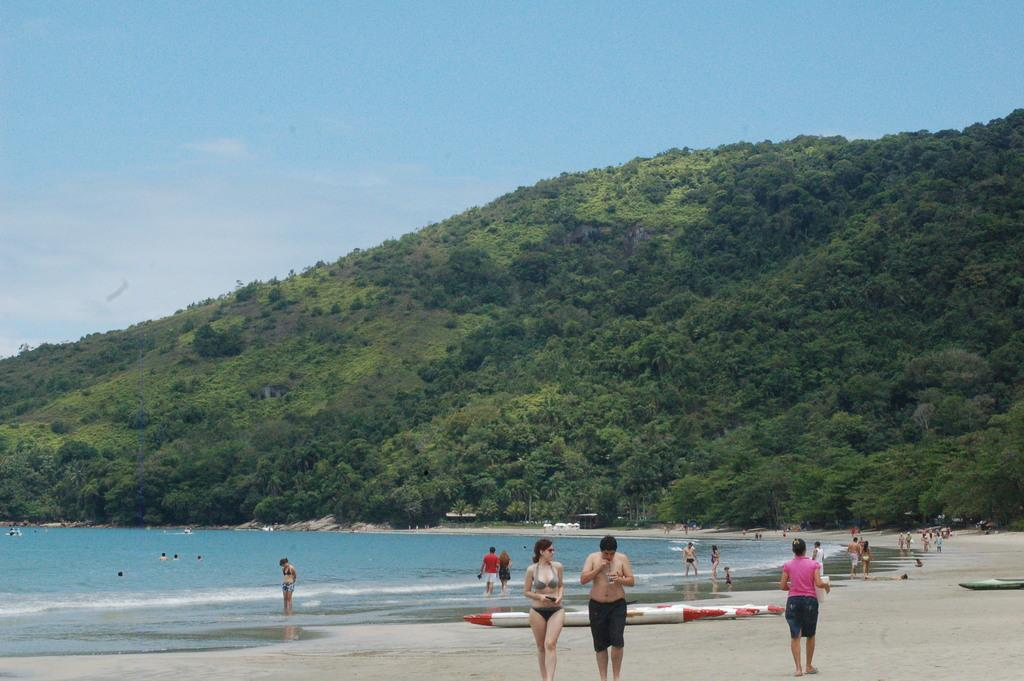How many people are in the group visible in the image? There is a group of people in the image, but the exact number cannot be determined from the provided facts. What type of location is depicted in the image? The image features a beach at the bottom. What is present on the beach? Sand is present at the beach. What can be seen in the background of the image? There are trees and mountains in the background of the image. What is visible at the top of the image? The sky is visible at the top of the image. What type of fruit is being advertised on the beach in the image? There is no fruit or advertisement present in the image; it features a group of people, a beach, sand, trees, mountains, and the sky. 